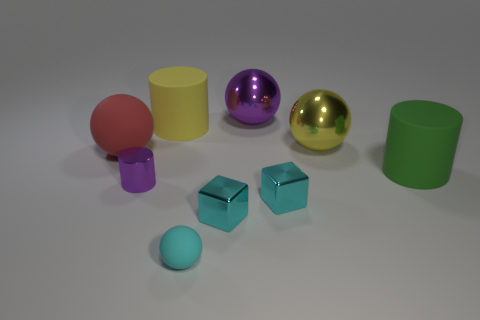Do the red rubber thing and the purple metallic sphere have the same size?
Make the answer very short. Yes. How many things are cylinders behind the red matte sphere or large matte things?
Your response must be concise. 3. The big object that is in front of the rubber sphere to the left of the tiny purple shiny cylinder is made of what material?
Offer a terse response. Rubber. Are there any purple things that have the same shape as the small cyan rubber object?
Provide a succinct answer. Yes. Is the size of the green cylinder the same as the purple metallic object right of the cyan matte ball?
Your answer should be very brief. Yes. How many things are tiny metallic things left of the small cyan matte sphere or tiny objects on the left side of the cyan rubber object?
Your response must be concise. 1. Are there more shiny balls that are left of the big purple metallic object than gray objects?
Provide a succinct answer. No. How many yellow matte cylinders have the same size as the yellow metal object?
Make the answer very short. 1. There is a purple object that is on the right side of the small cylinder; is it the same size as the rubber sphere that is in front of the big red sphere?
Make the answer very short. No. There is a purple shiny thing on the right side of the shiny cylinder; how big is it?
Make the answer very short. Large. 